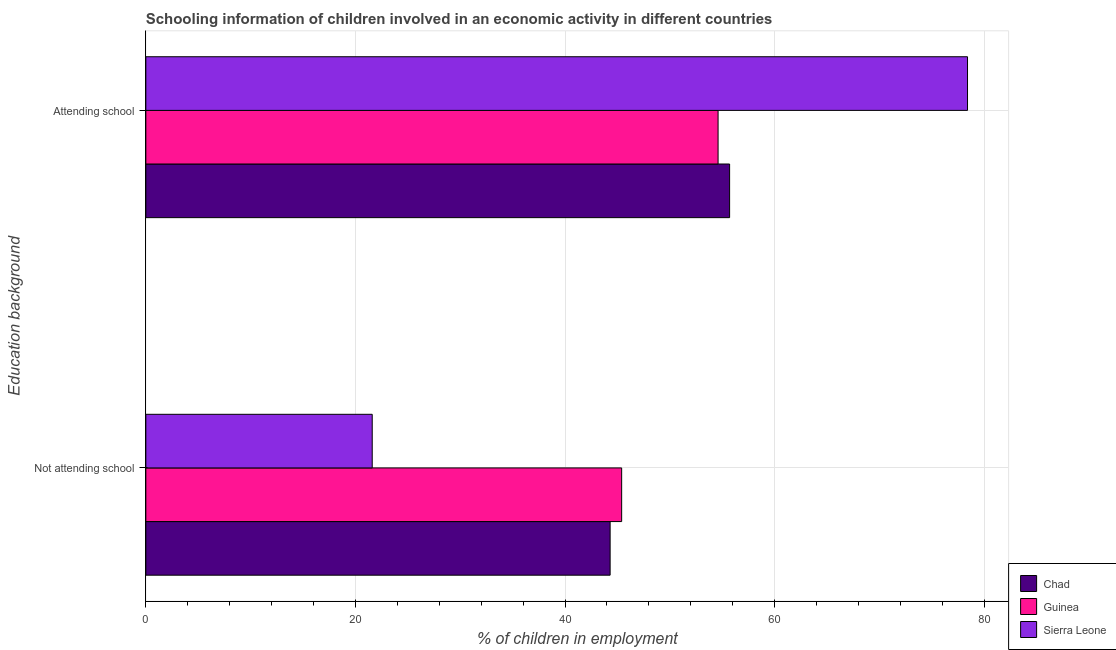How many groups of bars are there?
Give a very brief answer. 2. How many bars are there on the 2nd tick from the top?
Make the answer very short. 3. What is the label of the 1st group of bars from the top?
Your answer should be compact. Attending school. What is the percentage of employed children who are not attending school in Guinea?
Your answer should be very brief. 45.4. Across all countries, what is the maximum percentage of employed children who are attending school?
Make the answer very short. 78.4. Across all countries, what is the minimum percentage of employed children who are attending school?
Keep it short and to the point. 54.6. In which country was the percentage of employed children who are attending school maximum?
Provide a short and direct response. Sierra Leone. In which country was the percentage of employed children who are not attending school minimum?
Offer a very short reply. Sierra Leone. What is the total percentage of employed children who are not attending school in the graph?
Provide a succinct answer. 111.3. What is the difference between the percentage of employed children who are not attending school in Sierra Leone and that in Guinea?
Make the answer very short. -23.8. What is the difference between the percentage of employed children who are not attending school in Guinea and the percentage of employed children who are attending school in Chad?
Your answer should be very brief. -10.3. What is the average percentage of employed children who are attending school per country?
Ensure brevity in your answer.  62.9. What is the difference between the percentage of employed children who are not attending school and percentage of employed children who are attending school in Guinea?
Your answer should be very brief. -9.2. In how many countries, is the percentage of employed children who are not attending school greater than 12 %?
Make the answer very short. 3. What is the ratio of the percentage of employed children who are attending school in Chad to that in Sierra Leone?
Make the answer very short. 0.71. Is the percentage of employed children who are not attending school in Sierra Leone less than that in Guinea?
Give a very brief answer. Yes. In how many countries, is the percentage of employed children who are attending school greater than the average percentage of employed children who are attending school taken over all countries?
Provide a succinct answer. 1. What does the 1st bar from the top in Attending school represents?
Provide a short and direct response. Sierra Leone. What does the 3rd bar from the bottom in Not attending school represents?
Your response must be concise. Sierra Leone. Are all the bars in the graph horizontal?
Your answer should be very brief. Yes. How many countries are there in the graph?
Provide a succinct answer. 3. What is the difference between two consecutive major ticks on the X-axis?
Provide a short and direct response. 20. Where does the legend appear in the graph?
Provide a succinct answer. Bottom right. How are the legend labels stacked?
Offer a very short reply. Vertical. What is the title of the graph?
Give a very brief answer. Schooling information of children involved in an economic activity in different countries. What is the label or title of the X-axis?
Keep it short and to the point. % of children in employment. What is the label or title of the Y-axis?
Your response must be concise. Education background. What is the % of children in employment of Chad in Not attending school?
Your answer should be very brief. 44.3. What is the % of children in employment of Guinea in Not attending school?
Provide a succinct answer. 45.4. What is the % of children in employment of Sierra Leone in Not attending school?
Offer a very short reply. 21.6. What is the % of children in employment in Chad in Attending school?
Provide a short and direct response. 55.7. What is the % of children in employment of Guinea in Attending school?
Give a very brief answer. 54.6. What is the % of children in employment of Sierra Leone in Attending school?
Your answer should be compact. 78.4. Across all Education background, what is the maximum % of children in employment of Chad?
Your answer should be compact. 55.7. Across all Education background, what is the maximum % of children in employment of Guinea?
Provide a short and direct response. 54.6. Across all Education background, what is the maximum % of children in employment in Sierra Leone?
Keep it short and to the point. 78.4. Across all Education background, what is the minimum % of children in employment of Chad?
Your response must be concise. 44.3. Across all Education background, what is the minimum % of children in employment in Guinea?
Your answer should be very brief. 45.4. Across all Education background, what is the minimum % of children in employment in Sierra Leone?
Your response must be concise. 21.6. What is the difference between the % of children in employment of Chad in Not attending school and that in Attending school?
Your answer should be compact. -11.4. What is the difference between the % of children in employment in Sierra Leone in Not attending school and that in Attending school?
Your answer should be compact. -56.8. What is the difference between the % of children in employment in Chad in Not attending school and the % of children in employment in Guinea in Attending school?
Provide a short and direct response. -10.3. What is the difference between the % of children in employment in Chad in Not attending school and the % of children in employment in Sierra Leone in Attending school?
Give a very brief answer. -34.1. What is the difference between the % of children in employment of Guinea in Not attending school and the % of children in employment of Sierra Leone in Attending school?
Provide a short and direct response. -33. What is the average % of children in employment of Chad per Education background?
Offer a very short reply. 50. What is the average % of children in employment in Guinea per Education background?
Provide a short and direct response. 50. What is the difference between the % of children in employment of Chad and % of children in employment of Sierra Leone in Not attending school?
Your answer should be compact. 22.7. What is the difference between the % of children in employment in Guinea and % of children in employment in Sierra Leone in Not attending school?
Make the answer very short. 23.8. What is the difference between the % of children in employment in Chad and % of children in employment in Sierra Leone in Attending school?
Make the answer very short. -22.7. What is the difference between the % of children in employment of Guinea and % of children in employment of Sierra Leone in Attending school?
Offer a very short reply. -23.8. What is the ratio of the % of children in employment of Chad in Not attending school to that in Attending school?
Provide a succinct answer. 0.8. What is the ratio of the % of children in employment of Guinea in Not attending school to that in Attending school?
Your answer should be very brief. 0.83. What is the ratio of the % of children in employment in Sierra Leone in Not attending school to that in Attending school?
Ensure brevity in your answer.  0.28. What is the difference between the highest and the second highest % of children in employment of Chad?
Provide a succinct answer. 11.4. What is the difference between the highest and the second highest % of children in employment in Sierra Leone?
Keep it short and to the point. 56.8. What is the difference between the highest and the lowest % of children in employment of Chad?
Your answer should be very brief. 11.4. What is the difference between the highest and the lowest % of children in employment in Sierra Leone?
Your response must be concise. 56.8. 